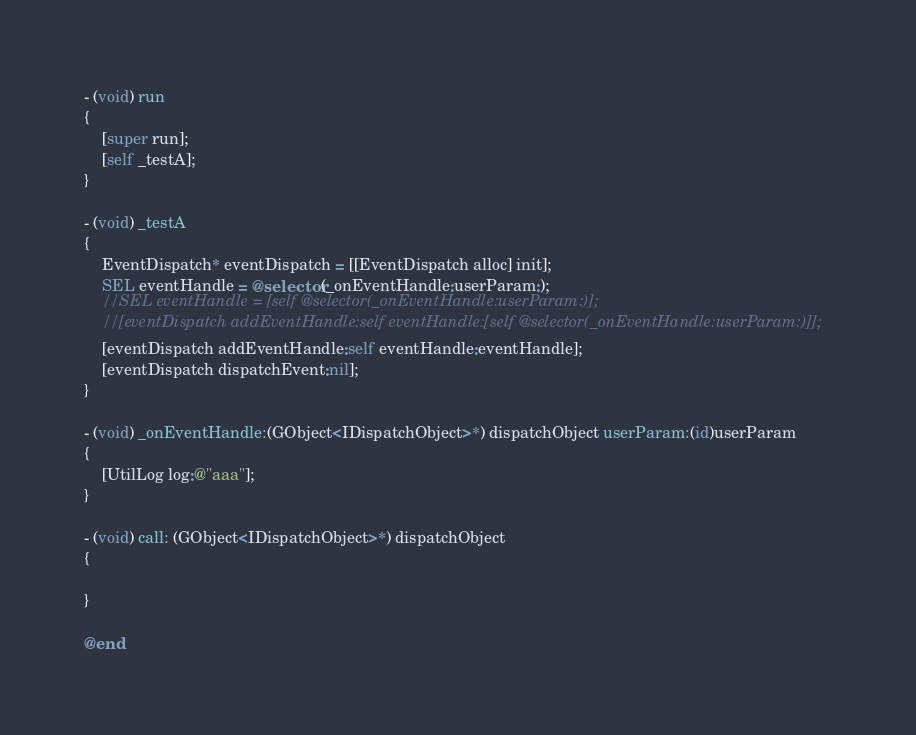<code> <loc_0><loc_0><loc_500><loc_500><_ObjectiveC_>- (void) run
{
    [super run];
    [self _testA];
}

- (void) _testA
{
    EventDispatch* eventDispatch = [[EventDispatch alloc] init];
    SEL eventHandle = @selector(_onEventHandle:userParam:);
    //SEL eventHandle = [self @selector(_onEventHandle:userParam:)];
    //[eventDispatch addEventHandle:self eventHandle:[self @selector(_onEventHandle:userParam:)]];
    [eventDispatch addEventHandle:self eventHandle:eventHandle];
    [eventDispatch dispatchEvent:nil];
}

- (void) _onEventHandle:(GObject<IDispatchObject>*) dispatchObject userParam:(id)userParam
{
    [UtilLog log:@"aaa"];
}

- (void) call: (GObject<IDispatchObject>*) dispatchObject
{
    
}

@end
</code> 